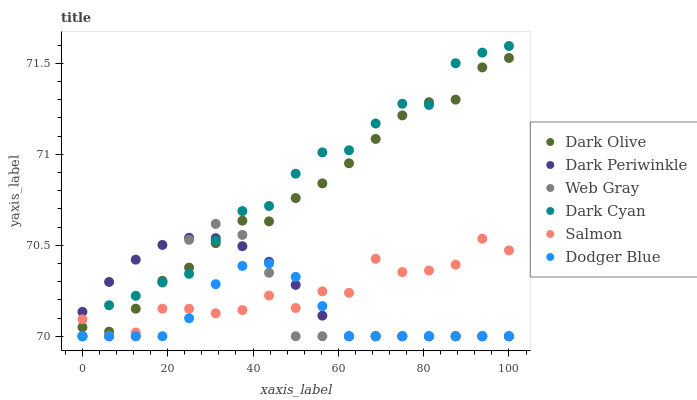Does Dodger Blue have the minimum area under the curve?
Answer yes or no. Yes. Does Dark Cyan have the maximum area under the curve?
Answer yes or no. Yes. Does Dark Olive have the minimum area under the curve?
Answer yes or no. No. Does Dark Olive have the maximum area under the curve?
Answer yes or no. No. Is Dark Periwinkle the smoothest?
Answer yes or no. Yes. Is Salmon the roughest?
Answer yes or no. Yes. Is Dark Olive the smoothest?
Answer yes or no. No. Is Dark Olive the roughest?
Answer yes or no. No. Does Web Gray have the lowest value?
Answer yes or no. Yes. Does Dark Olive have the lowest value?
Answer yes or no. No. Does Dark Cyan have the highest value?
Answer yes or no. Yes. Does Dark Olive have the highest value?
Answer yes or no. No. Is Dodger Blue less than Dark Olive?
Answer yes or no. Yes. Is Dark Olive greater than Dodger Blue?
Answer yes or no. Yes. Does Dark Olive intersect Salmon?
Answer yes or no. Yes. Is Dark Olive less than Salmon?
Answer yes or no. No. Is Dark Olive greater than Salmon?
Answer yes or no. No. Does Dodger Blue intersect Dark Olive?
Answer yes or no. No. 